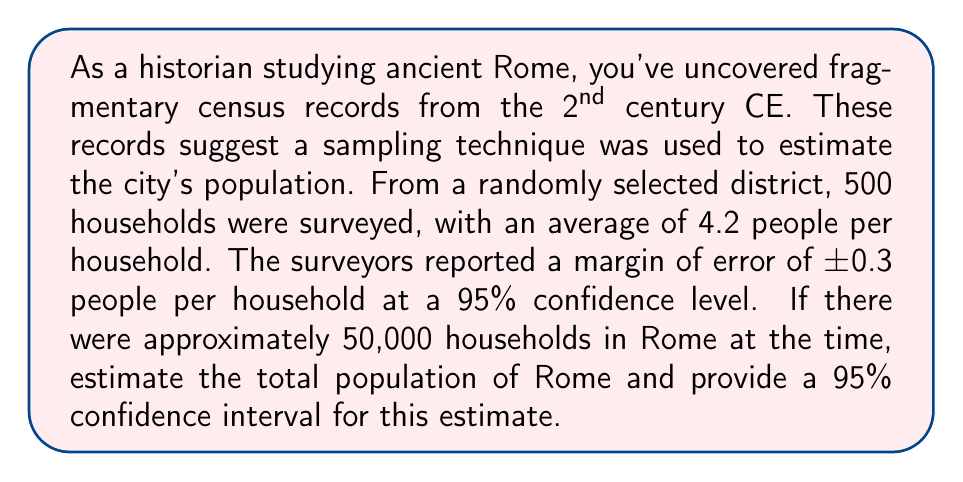Can you solve this math problem? To solve this problem, we'll use statistical sampling techniques and confidence intervals. Let's break it down step-by-step:

1. Calculate the point estimate for Rome's population:
   - Average people per household: 4.2
   - Total households: 50,000
   - Point estimate = $4.2 \times 50,000 = 210,000$

2. Calculate the margin of error for the total population:
   - Margin of error per household: ±0.3
   - Total households: 50,000
   - Margin of error for population = $0.3 \times 50,000 = 15,000$

3. Construct the 95% confidence interval:
   - Lower bound = Point estimate - Margin of error
   - Upper bound = Point estimate + Margin of error
   
   $CI = 210,000 \pm 15,000$
   $CI = [195,000, 225,000]$

4. Interpret the results:
   We can say with 95% confidence that the true population of Rome in the 2nd century CE was between 195,000 and 225,000 people.

To verify the margin of error, we can use the formula:

$$ ME = z \times \frac{\sigma}{\sqrt{n}} \times \sqrt{\frac{N-n}{N-1}} $$

Where:
- $z$ is the z-score for 95% confidence (1.96)
- $\sigma$ is the standard deviation (which we don't have, but can estimate)
- $n$ is the sample size (500)
- $N$ is the population size (50,000)

However, since we're given the margin of error directly, we don't need to perform this calculation.
Answer: The estimated population of Rome in the 2nd century CE was 210,000, with a 95% confidence interval of [195,000, 225,000]. 